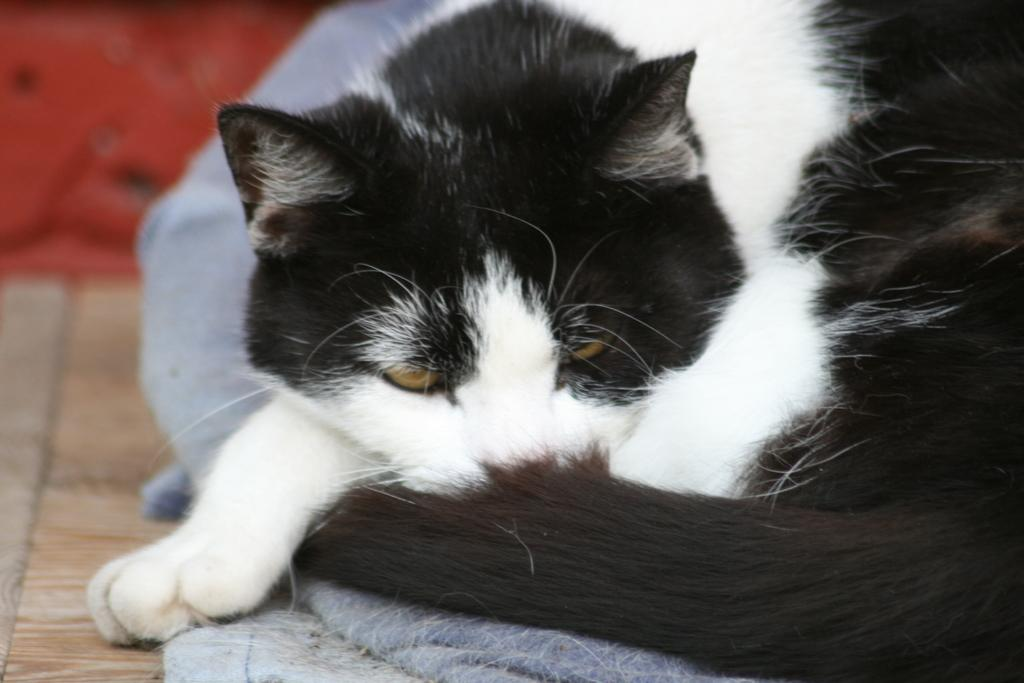Where was the image taken? The image is taken indoors. What can be seen at the bottom of the image? There is a floor visible at the bottom of the image. What animal is on the right side of the image? There is a cat on the right side of the image. What is the cat sitting on? The cat is on a towel. What is visible in the background of the image? There is a wall in the background of the image. What nation is the woman from in the image? There is no woman present in the image, only a cat on a towel. 